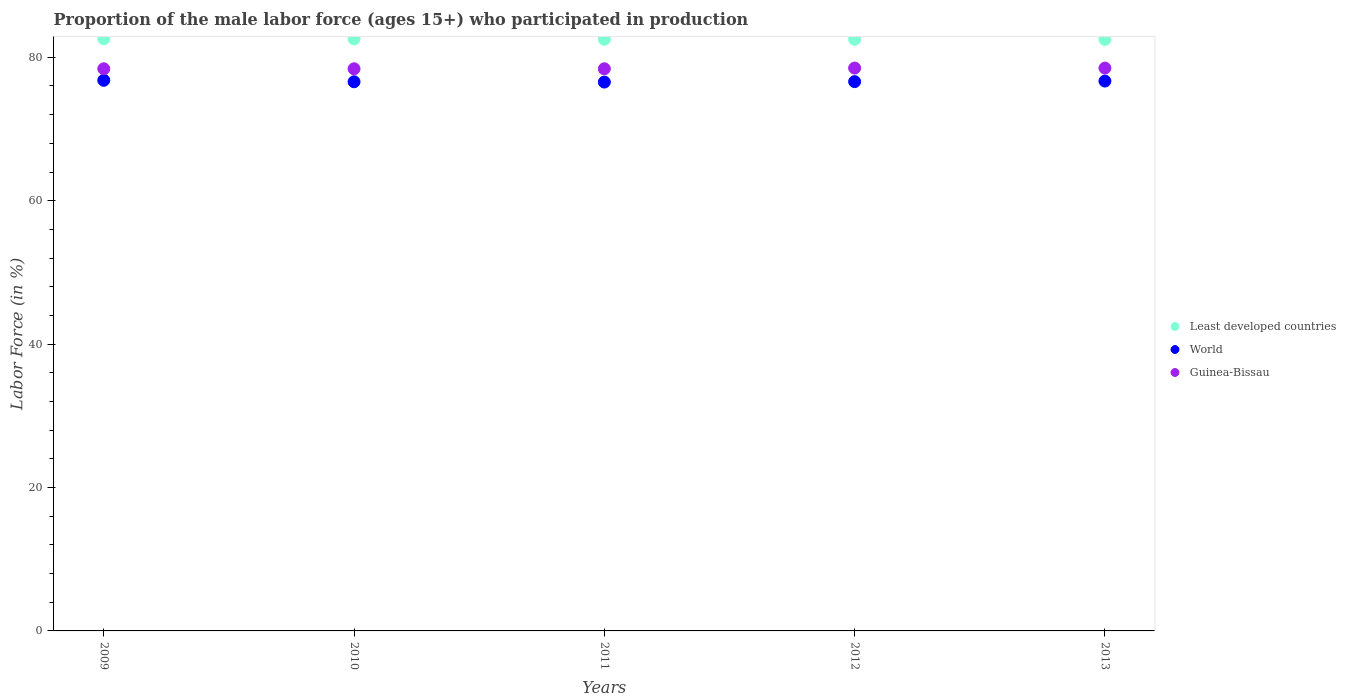How many different coloured dotlines are there?
Your response must be concise. 3. Is the number of dotlines equal to the number of legend labels?
Keep it short and to the point. Yes. What is the proportion of the male labor force who participated in production in Guinea-Bissau in 2012?
Keep it short and to the point. 78.5. Across all years, what is the maximum proportion of the male labor force who participated in production in Guinea-Bissau?
Offer a very short reply. 78.5. Across all years, what is the minimum proportion of the male labor force who participated in production in Least developed countries?
Keep it short and to the point. 82.5. In which year was the proportion of the male labor force who participated in production in World maximum?
Offer a terse response. 2009. In which year was the proportion of the male labor force who participated in production in Guinea-Bissau minimum?
Offer a terse response. 2009. What is the total proportion of the male labor force who participated in production in Least developed countries in the graph?
Ensure brevity in your answer.  412.67. What is the difference between the proportion of the male labor force who participated in production in Guinea-Bissau in 2009 and that in 2010?
Offer a very short reply. 0. What is the difference between the proportion of the male labor force who participated in production in Least developed countries in 2011 and the proportion of the male labor force who participated in production in World in 2009?
Offer a terse response. 5.72. What is the average proportion of the male labor force who participated in production in Least developed countries per year?
Give a very brief answer. 82.53. In the year 2012, what is the difference between the proportion of the male labor force who participated in production in World and proportion of the male labor force who participated in production in Guinea-Bissau?
Ensure brevity in your answer.  -1.89. In how many years, is the proportion of the male labor force who participated in production in Least developed countries greater than 40 %?
Offer a terse response. 5. What is the ratio of the proportion of the male labor force who participated in production in World in 2009 to that in 2013?
Give a very brief answer. 1. Is the proportion of the male labor force who participated in production in World in 2010 less than that in 2011?
Your answer should be compact. No. Is the difference between the proportion of the male labor force who participated in production in World in 2009 and 2013 greater than the difference between the proportion of the male labor force who participated in production in Guinea-Bissau in 2009 and 2013?
Provide a succinct answer. Yes. What is the difference between the highest and the second highest proportion of the male labor force who participated in production in Guinea-Bissau?
Keep it short and to the point. 0. What is the difference between the highest and the lowest proportion of the male labor force who participated in production in Least developed countries?
Give a very brief answer. 0.09. In how many years, is the proportion of the male labor force who participated in production in Least developed countries greater than the average proportion of the male labor force who participated in production in Least developed countries taken over all years?
Provide a short and direct response. 2. Is the sum of the proportion of the male labor force who participated in production in World in 2009 and 2013 greater than the maximum proportion of the male labor force who participated in production in Least developed countries across all years?
Make the answer very short. Yes. Is the proportion of the male labor force who participated in production in Least developed countries strictly greater than the proportion of the male labor force who participated in production in World over the years?
Keep it short and to the point. Yes. Is the proportion of the male labor force who participated in production in Least developed countries strictly less than the proportion of the male labor force who participated in production in World over the years?
Offer a terse response. No. How many dotlines are there?
Keep it short and to the point. 3. How many years are there in the graph?
Offer a very short reply. 5. What is the difference between two consecutive major ticks on the Y-axis?
Ensure brevity in your answer.  20. Are the values on the major ticks of Y-axis written in scientific E-notation?
Make the answer very short. No. Does the graph contain any zero values?
Offer a very short reply. No. Does the graph contain grids?
Your answer should be very brief. No. Where does the legend appear in the graph?
Offer a very short reply. Center right. What is the title of the graph?
Your answer should be very brief. Proportion of the male labor force (ages 15+) who participated in production. Does "Least developed countries" appear as one of the legend labels in the graph?
Provide a short and direct response. Yes. What is the label or title of the X-axis?
Ensure brevity in your answer.  Years. What is the label or title of the Y-axis?
Offer a very short reply. Labor Force (in %). What is the Labor Force (in %) of Least developed countries in 2009?
Offer a very short reply. 82.59. What is the Labor Force (in %) of World in 2009?
Offer a very short reply. 76.79. What is the Labor Force (in %) of Guinea-Bissau in 2009?
Keep it short and to the point. 78.4. What is the Labor Force (in %) of Least developed countries in 2010?
Give a very brief answer. 82.57. What is the Labor Force (in %) of World in 2010?
Provide a short and direct response. 76.59. What is the Labor Force (in %) in Guinea-Bissau in 2010?
Ensure brevity in your answer.  78.4. What is the Labor Force (in %) of Least developed countries in 2011?
Offer a terse response. 82.52. What is the Labor Force (in %) of World in 2011?
Keep it short and to the point. 76.55. What is the Labor Force (in %) of Guinea-Bissau in 2011?
Your answer should be compact. 78.4. What is the Labor Force (in %) in Least developed countries in 2012?
Your response must be concise. 82.5. What is the Labor Force (in %) in World in 2012?
Keep it short and to the point. 76.61. What is the Labor Force (in %) in Guinea-Bissau in 2012?
Offer a terse response. 78.5. What is the Labor Force (in %) in Least developed countries in 2013?
Keep it short and to the point. 82.5. What is the Labor Force (in %) in World in 2013?
Your answer should be compact. 76.69. What is the Labor Force (in %) of Guinea-Bissau in 2013?
Offer a terse response. 78.5. Across all years, what is the maximum Labor Force (in %) in Least developed countries?
Your answer should be compact. 82.59. Across all years, what is the maximum Labor Force (in %) in World?
Ensure brevity in your answer.  76.79. Across all years, what is the maximum Labor Force (in %) in Guinea-Bissau?
Your response must be concise. 78.5. Across all years, what is the minimum Labor Force (in %) in Least developed countries?
Your answer should be compact. 82.5. Across all years, what is the minimum Labor Force (in %) in World?
Offer a terse response. 76.55. Across all years, what is the minimum Labor Force (in %) of Guinea-Bissau?
Your answer should be very brief. 78.4. What is the total Labor Force (in %) of Least developed countries in the graph?
Offer a terse response. 412.67. What is the total Labor Force (in %) of World in the graph?
Your answer should be compact. 383.22. What is the total Labor Force (in %) in Guinea-Bissau in the graph?
Your answer should be compact. 392.2. What is the difference between the Labor Force (in %) of Least developed countries in 2009 and that in 2010?
Offer a terse response. 0.02. What is the difference between the Labor Force (in %) in World in 2009 and that in 2010?
Your response must be concise. 0.21. What is the difference between the Labor Force (in %) of Least developed countries in 2009 and that in 2011?
Offer a very short reply. 0.07. What is the difference between the Labor Force (in %) in World in 2009 and that in 2011?
Offer a very short reply. 0.25. What is the difference between the Labor Force (in %) of Least developed countries in 2009 and that in 2012?
Offer a very short reply. 0.08. What is the difference between the Labor Force (in %) of World in 2009 and that in 2012?
Make the answer very short. 0.19. What is the difference between the Labor Force (in %) in Guinea-Bissau in 2009 and that in 2012?
Provide a short and direct response. -0.1. What is the difference between the Labor Force (in %) of Least developed countries in 2009 and that in 2013?
Give a very brief answer. 0.09. What is the difference between the Labor Force (in %) in World in 2009 and that in 2013?
Provide a succinct answer. 0.11. What is the difference between the Labor Force (in %) of Guinea-Bissau in 2009 and that in 2013?
Make the answer very short. -0.1. What is the difference between the Labor Force (in %) of Least developed countries in 2010 and that in 2011?
Offer a very short reply. 0.05. What is the difference between the Labor Force (in %) in World in 2010 and that in 2011?
Offer a terse response. 0.04. What is the difference between the Labor Force (in %) of Guinea-Bissau in 2010 and that in 2011?
Offer a terse response. 0. What is the difference between the Labor Force (in %) in Least developed countries in 2010 and that in 2012?
Offer a terse response. 0.06. What is the difference between the Labor Force (in %) of World in 2010 and that in 2012?
Your answer should be compact. -0.02. What is the difference between the Labor Force (in %) of Least developed countries in 2010 and that in 2013?
Keep it short and to the point. 0.07. What is the difference between the Labor Force (in %) in World in 2010 and that in 2013?
Provide a succinct answer. -0.1. What is the difference between the Labor Force (in %) in Guinea-Bissau in 2010 and that in 2013?
Your answer should be very brief. -0.1. What is the difference between the Labor Force (in %) of Least developed countries in 2011 and that in 2012?
Offer a terse response. 0.01. What is the difference between the Labor Force (in %) in World in 2011 and that in 2012?
Provide a short and direct response. -0.06. What is the difference between the Labor Force (in %) in Guinea-Bissau in 2011 and that in 2012?
Offer a very short reply. -0.1. What is the difference between the Labor Force (in %) in Least developed countries in 2011 and that in 2013?
Your answer should be very brief. 0.02. What is the difference between the Labor Force (in %) in World in 2011 and that in 2013?
Ensure brevity in your answer.  -0.14. What is the difference between the Labor Force (in %) of Guinea-Bissau in 2011 and that in 2013?
Make the answer very short. -0.1. What is the difference between the Labor Force (in %) in Least developed countries in 2012 and that in 2013?
Offer a very short reply. 0.01. What is the difference between the Labor Force (in %) in World in 2012 and that in 2013?
Provide a short and direct response. -0.08. What is the difference between the Labor Force (in %) of Least developed countries in 2009 and the Labor Force (in %) of World in 2010?
Provide a short and direct response. 6. What is the difference between the Labor Force (in %) of Least developed countries in 2009 and the Labor Force (in %) of Guinea-Bissau in 2010?
Your answer should be very brief. 4.19. What is the difference between the Labor Force (in %) of World in 2009 and the Labor Force (in %) of Guinea-Bissau in 2010?
Keep it short and to the point. -1.61. What is the difference between the Labor Force (in %) of Least developed countries in 2009 and the Labor Force (in %) of World in 2011?
Offer a very short reply. 6.04. What is the difference between the Labor Force (in %) of Least developed countries in 2009 and the Labor Force (in %) of Guinea-Bissau in 2011?
Make the answer very short. 4.19. What is the difference between the Labor Force (in %) in World in 2009 and the Labor Force (in %) in Guinea-Bissau in 2011?
Provide a succinct answer. -1.61. What is the difference between the Labor Force (in %) in Least developed countries in 2009 and the Labor Force (in %) in World in 2012?
Your answer should be very brief. 5.98. What is the difference between the Labor Force (in %) in Least developed countries in 2009 and the Labor Force (in %) in Guinea-Bissau in 2012?
Ensure brevity in your answer.  4.09. What is the difference between the Labor Force (in %) of World in 2009 and the Labor Force (in %) of Guinea-Bissau in 2012?
Offer a very short reply. -1.71. What is the difference between the Labor Force (in %) of Least developed countries in 2009 and the Labor Force (in %) of World in 2013?
Give a very brief answer. 5.9. What is the difference between the Labor Force (in %) of Least developed countries in 2009 and the Labor Force (in %) of Guinea-Bissau in 2013?
Your response must be concise. 4.09. What is the difference between the Labor Force (in %) of World in 2009 and the Labor Force (in %) of Guinea-Bissau in 2013?
Ensure brevity in your answer.  -1.71. What is the difference between the Labor Force (in %) of Least developed countries in 2010 and the Labor Force (in %) of World in 2011?
Your answer should be compact. 6.02. What is the difference between the Labor Force (in %) of Least developed countries in 2010 and the Labor Force (in %) of Guinea-Bissau in 2011?
Provide a succinct answer. 4.17. What is the difference between the Labor Force (in %) in World in 2010 and the Labor Force (in %) in Guinea-Bissau in 2011?
Give a very brief answer. -1.81. What is the difference between the Labor Force (in %) of Least developed countries in 2010 and the Labor Force (in %) of World in 2012?
Provide a short and direct response. 5.96. What is the difference between the Labor Force (in %) of Least developed countries in 2010 and the Labor Force (in %) of Guinea-Bissau in 2012?
Offer a very short reply. 4.07. What is the difference between the Labor Force (in %) of World in 2010 and the Labor Force (in %) of Guinea-Bissau in 2012?
Your answer should be very brief. -1.91. What is the difference between the Labor Force (in %) in Least developed countries in 2010 and the Labor Force (in %) in World in 2013?
Make the answer very short. 5.88. What is the difference between the Labor Force (in %) of Least developed countries in 2010 and the Labor Force (in %) of Guinea-Bissau in 2013?
Give a very brief answer. 4.07. What is the difference between the Labor Force (in %) in World in 2010 and the Labor Force (in %) in Guinea-Bissau in 2013?
Keep it short and to the point. -1.91. What is the difference between the Labor Force (in %) of Least developed countries in 2011 and the Labor Force (in %) of World in 2012?
Your answer should be very brief. 5.91. What is the difference between the Labor Force (in %) of Least developed countries in 2011 and the Labor Force (in %) of Guinea-Bissau in 2012?
Provide a short and direct response. 4.02. What is the difference between the Labor Force (in %) of World in 2011 and the Labor Force (in %) of Guinea-Bissau in 2012?
Your response must be concise. -1.95. What is the difference between the Labor Force (in %) of Least developed countries in 2011 and the Labor Force (in %) of World in 2013?
Ensure brevity in your answer.  5.83. What is the difference between the Labor Force (in %) in Least developed countries in 2011 and the Labor Force (in %) in Guinea-Bissau in 2013?
Provide a short and direct response. 4.02. What is the difference between the Labor Force (in %) of World in 2011 and the Labor Force (in %) of Guinea-Bissau in 2013?
Offer a very short reply. -1.95. What is the difference between the Labor Force (in %) of Least developed countries in 2012 and the Labor Force (in %) of World in 2013?
Ensure brevity in your answer.  5.82. What is the difference between the Labor Force (in %) of Least developed countries in 2012 and the Labor Force (in %) of Guinea-Bissau in 2013?
Provide a short and direct response. 4. What is the difference between the Labor Force (in %) in World in 2012 and the Labor Force (in %) in Guinea-Bissau in 2013?
Offer a terse response. -1.89. What is the average Labor Force (in %) in Least developed countries per year?
Your answer should be very brief. 82.53. What is the average Labor Force (in %) in World per year?
Make the answer very short. 76.64. What is the average Labor Force (in %) in Guinea-Bissau per year?
Your answer should be compact. 78.44. In the year 2009, what is the difference between the Labor Force (in %) in Least developed countries and Labor Force (in %) in World?
Offer a very short reply. 5.79. In the year 2009, what is the difference between the Labor Force (in %) of Least developed countries and Labor Force (in %) of Guinea-Bissau?
Offer a very short reply. 4.19. In the year 2009, what is the difference between the Labor Force (in %) in World and Labor Force (in %) in Guinea-Bissau?
Provide a short and direct response. -1.61. In the year 2010, what is the difference between the Labor Force (in %) in Least developed countries and Labor Force (in %) in World?
Your response must be concise. 5.98. In the year 2010, what is the difference between the Labor Force (in %) of Least developed countries and Labor Force (in %) of Guinea-Bissau?
Make the answer very short. 4.17. In the year 2010, what is the difference between the Labor Force (in %) of World and Labor Force (in %) of Guinea-Bissau?
Provide a short and direct response. -1.81. In the year 2011, what is the difference between the Labor Force (in %) of Least developed countries and Labor Force (in %) of World?
Give a very brief answer. 5.97. In the year 2011, what is the difference between the Labor Force (in %) of Least developed countries and Labor Force (in %) of Guinea-Bissau?
Your answer should be compact. 4.12. In the year 2011, what is the difference between the Labor Force (in %) of World and Labor Force (in %) of Guinea-Bissau?
Give a very brief answer. -1.85. In the year 2012, what is the difference between the Labor Force (in %) in Least developed countries and Labor Force (in %) in World?
Your answer should be very brief. 5.9. In the year 2012, what is the difference between the Labor Force (in %) of Least developed countries and Labor Force (in %) of Guinea-Bissau?
Your response must be concise. 4. In the year 2012, what is the difference between the Labor Force (in %) of World and Labor Force (in %) of Guinea-Bissau?
Provide a short and direct response. -1.89. In the year 2013, what is the difference between the Labor Force (in %) of Least developed countries and Labor Force (in %) of World?
Provide a succinct answer. 5.81. In the year 2013, what is the difference between the Labor Force (in %) in Least developed countries and Labor Force (in %) in Guinea-Bissau?
Your response must be concise. 4. In the year 2013, what is the difference between the Labor Force (in %) of World and Labor Force (in %) of Guinea-Bissau?
Offer a terse response. -1.81. What is the ratio of the Labor Force (in %) in Guinea-Bissau in 2009 to that in 2010?
Offer a very short reply. 1. What is the ratio of the Labor Force (in %) of Least developed countries in 2009 to that in 2011?
Your response must be concise. 1. What is the ratio of the Labor Force (in %) of Guinea-Bissau in 2009 to that in 2011?
Make the answer very short. 1. What is the ratio of the Labor Force (in %) of Least developed countries in 2009 to that in 2012?
Provide a short and direct response. 1. What is the ratio of the Labor Force (in %) in World in 2009 to that in 2012?
Provide a short and direct response. 1. What is the ratio of the Labor Force (in %) in Guinea-Bissau in 2009 to that in 2012?
Your answer should be compact. 1. What is the ratio of the Labor Force (in %) in Least developed countries in 2009 to that in 2013?
Offer a very short reply. 1. What is the ratio of the Labor Force (in %) in World in 2009 to that in 2013?
Give a very brief answer. 1. What is the ratio of the Labor Force (in %) in Guinea-Bissau in 2009 to that in 2013?
Provide a short and direct response. 1. What is the ratio of the Labor Force (in %) of World in 2010 to that in 2011?
Offer a very short reply. 1. What is the ratio of the Labor Force (in %) in Least developed countries in 2010 to that in 2012?
Your answer should be compact. 1. What is the ratio of the Labor Force (in %) of Least developed countries in 2010 to that in 2013?
Make the answer very short. 1. What is the ratio of the Labor Force (in %) in World in 2010 to that in 2013?
Keep it short and to the point. 1. What is the ratio of the Labor Force (in %) in Least developed countries in 2011 to that in 2012?
Give a very brief answer. 1. What is the ratio of the Labor Force (in %) in World in 2011 to that in 2012?
Provide a succinct answer. 1. What is the ratio of the Labor Force (in %) in Least developed countries in 2011 to that in 2013?
Make the answer very short. 1. What is the ratio of the Labor Force (in %) in World in 2011 to that in 2013?
Your answer should be compact. 1. What is the ratio of the Labor Force (in %) of Guinea-Bissau in 2011 to that in 2013?
Provide a short and direct response. 1. What is the ratio of the Labor Force (in %) of Least developed countries in 2012 to that in 2013?
Offer a terse response. 1. What is the ratio of the Labor Force (in %) in World in 2012 to that in 2013?
Your answer should be very brief. 1. What is the ratio of the Labor Force (in %) of Guinea-Bissau in 2012 to that in 2013?
Ensure brevity in your answer.  1. What is the difference between the highest and the second highest Labor Force (in %) of Least developed countries?
Your response must be concise. 0.02. What is the difference between the highest and the second highest Labor Force (in %) in World?
Your answer should be very brief. 0.11. What is the difference between the highest and the second highest Labor Force (in %) of Guinea-Bissau?
Your answer should be very brief. 0. What is the difference between the highest and the lowest Labor Force (in %) of Least developed countries?
Provide a short and direct response. 0.09. What is the difference between the highest and the lowest Labor Force (in %) in World?
Give a very brief answer. 0.25. 